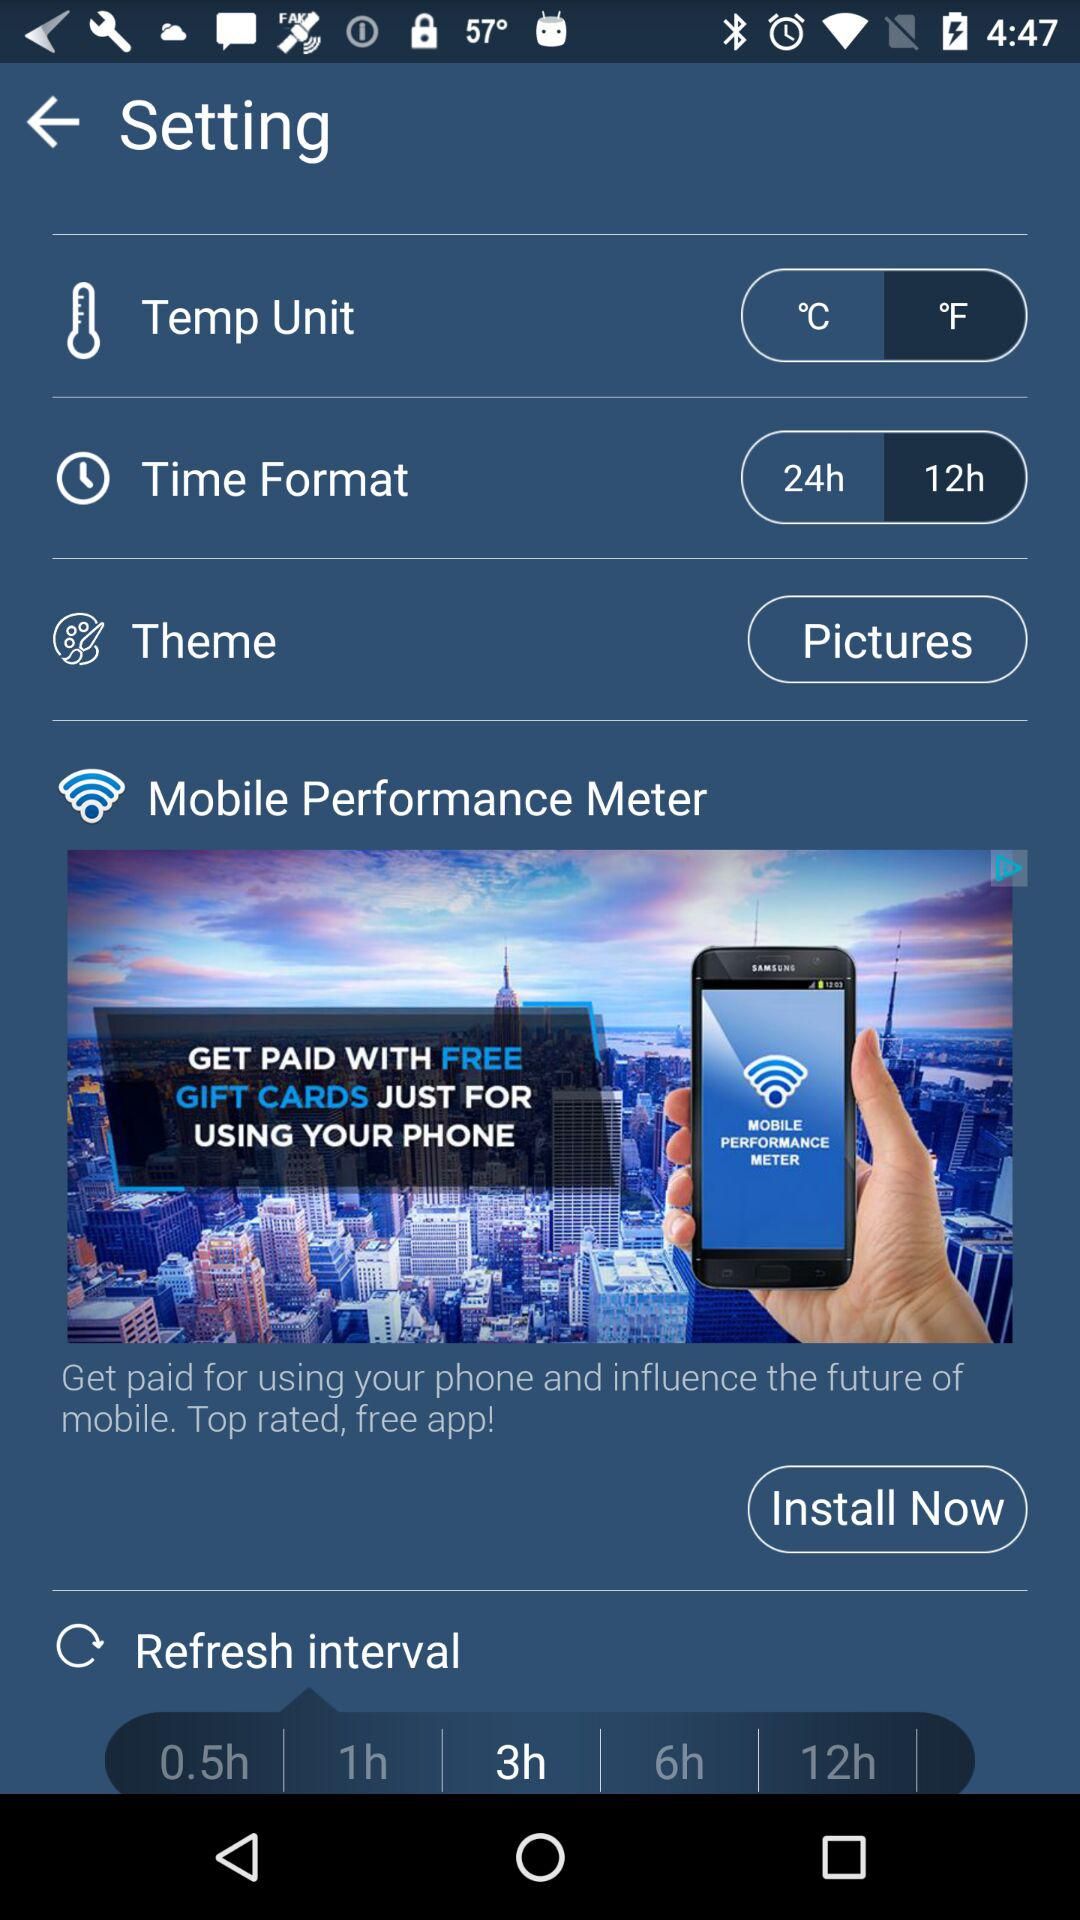Which option is selected in "Refresh Interval"? The selected option is "3h". 